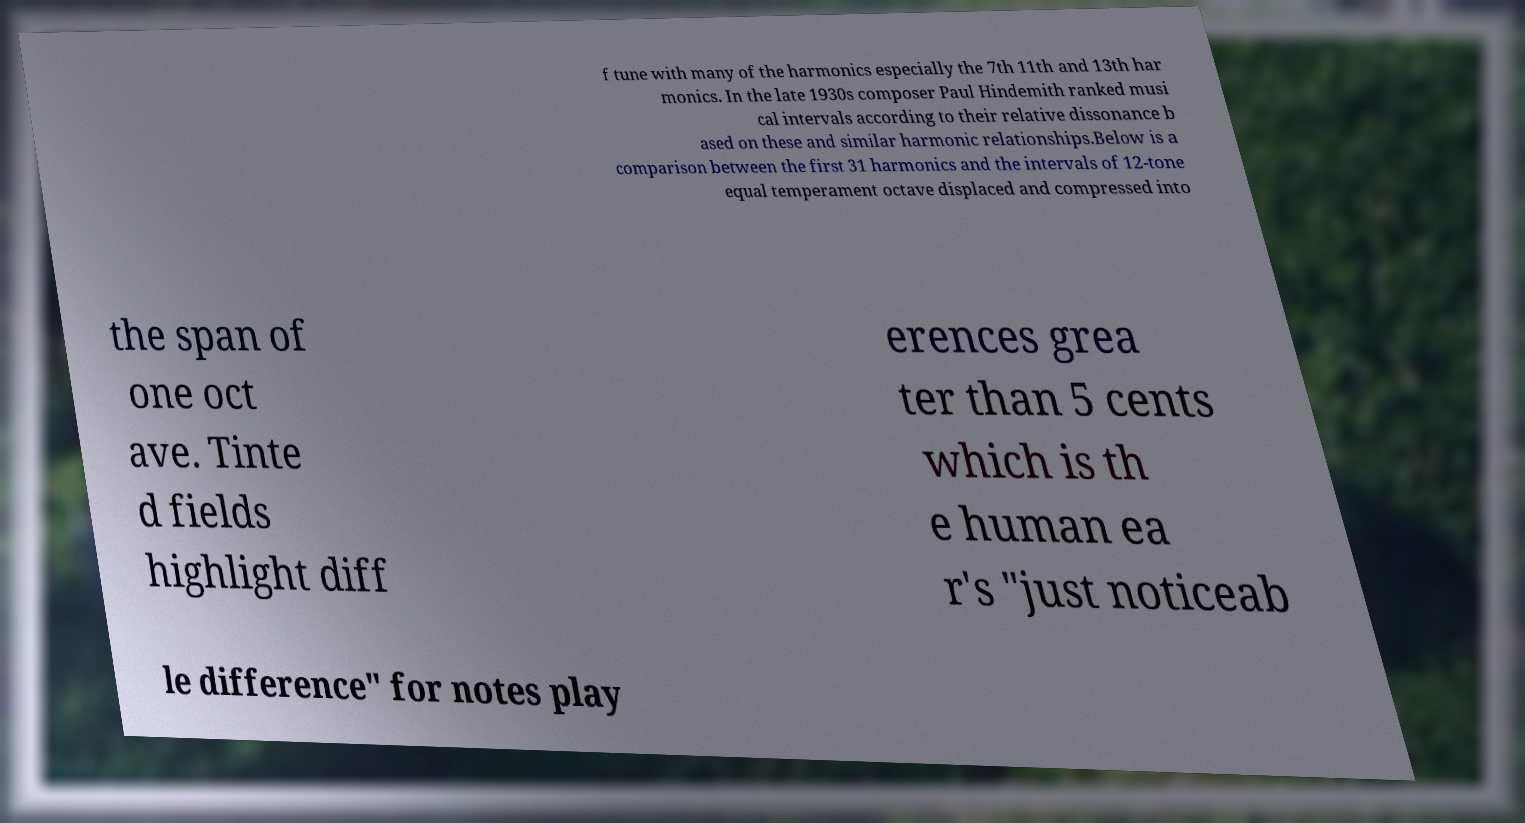What messages or text are displayed in this image? I need them in a readable, typed format. f tune with many of the harmonics especially the 7th 11th and 13th har monics. In the late 1930s composer Paul Hindemith ranked musi cal intervals according to their relative dissonance b ased on these and similar harmonic relationships.Below is a comparison between the first 31 harmonics and the intervals of 12-tone equal temperament octave displaced and compressed into the span of one oct ave. Tinte d fields highlight diff erences grea ter than 5 cents which is th e human ea r's "just noticeab le difference" for notes play 